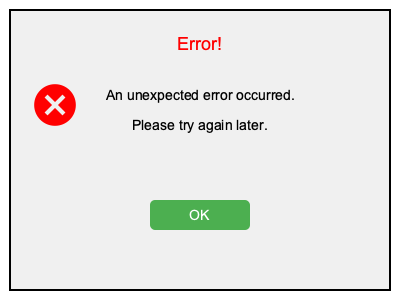Which arrangement of elements in the error pop-up maximizes readability and visual appeal? To arrange text and graphical elements for optimal readability in an error pop-up, follow these steps:

1. Hierarchy: Place the most important information at the top. In this case, "Error!" is at the top and in red to grab attention.

2. Typography: Use a clear, sans-serif font (Arial in this example) for better readability on screens. The error title is larger (18px) than the description (14px).

3. Alignment: Center-align text for a clean, balanced look. This is achieved using text-anchor="middle" and calculating the x-position.

4. White space: Leave ample space between elements to prevent cluttering. Notice the spacing between the title, description, and button.

5. Color contrast: Use high contrast colors for better visibility. Here, red is used for the error title, and white text on a green button for the "OK" action.

6. Visual cues: Include an error icon (top-left) to quickly convey the message type. The icon is placed near the text but not interfering with it.

7. Concise messaging: Keep the error message brief and clear, explaining what happened and what the user should do.

8. Clear call-to-action: Place an obvious "OK" button at the bottom, styled distinctly from other elements.

9. Consistent styling: Use a cohesive color scheme and styling throughout the pop-up for a professional look.

10. Responsive design: Ensure the pop-up is sized appropriately (380x280 pixels) to be visible on various screen sizes without overwhelming the interface.

This arrangement ensures that the error message is immediately noticeable, easy to read, and provides a clear next action for the user.
Answer: Hierarchical placement, clear typography, centered alignment, ample white space, high contrast colors, visual icon, concise messaging, distinct CTA button 